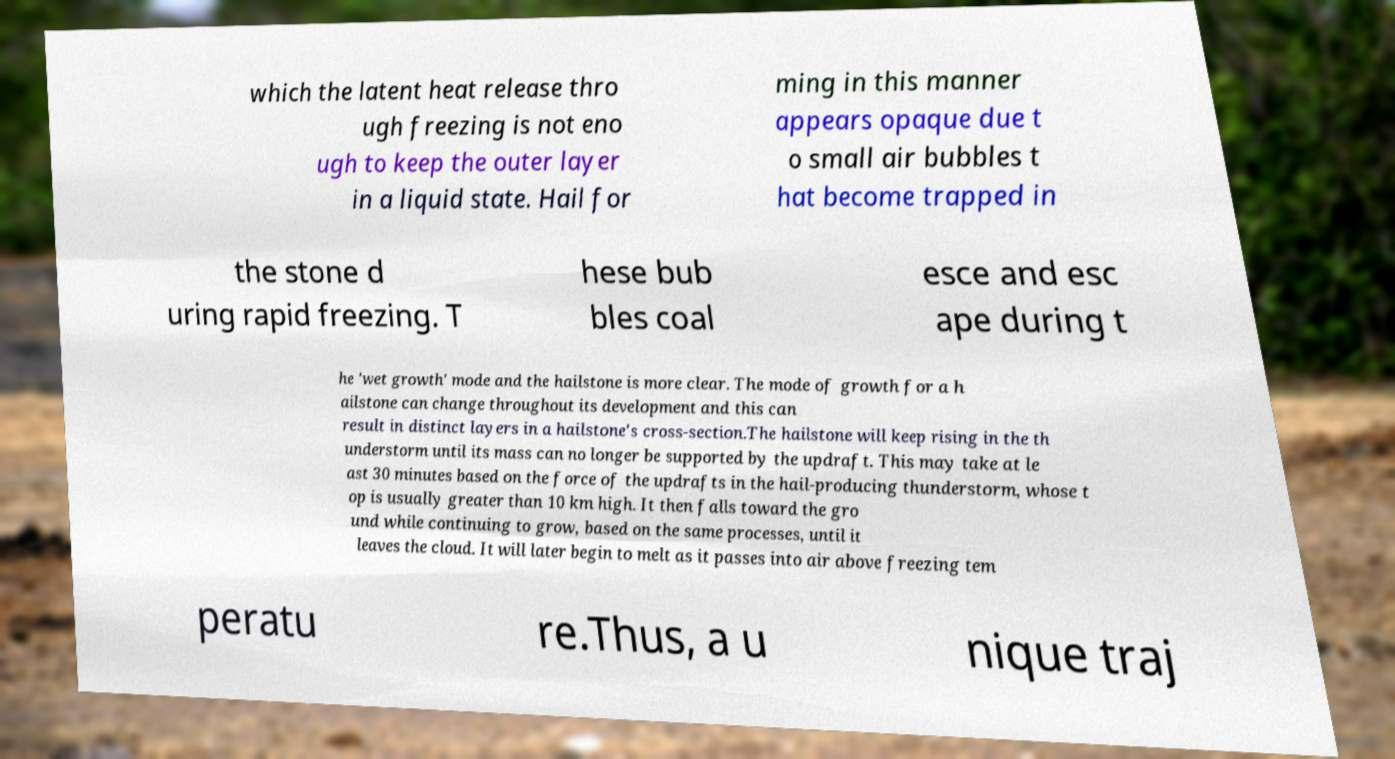Could you extract and type out the text from this image? which the latent heat release thro ugh freezing is not eno ugh to keep the outer layer in a liquid state. Hail for ming in this manner appears opaque due t o small air bubbles t hat become trapped in the stone d uring rapid freezing. T hese bub bles coal esce and esc ape during t he 'wet growth' mode and the hailstone is more clear. The mode of growth for a h ailstone can change throughout its development and this can result in distinct layers in a hailstone's cross-section.The hailstone will keep rising in the th understorm until its mass can no longer be supported by the updraft. This may take at le ast 30 minutes based on the force of the updrafts in the hail-producing thunderstorm, whose t op is usually greater than 10 km high. It then falls toward the gro und while continuing to grow, based on the same processes, until it leaves the cloud. It will later begin to melt as it passes into air above freezing tem peratu re.Thus, a u nique traj 